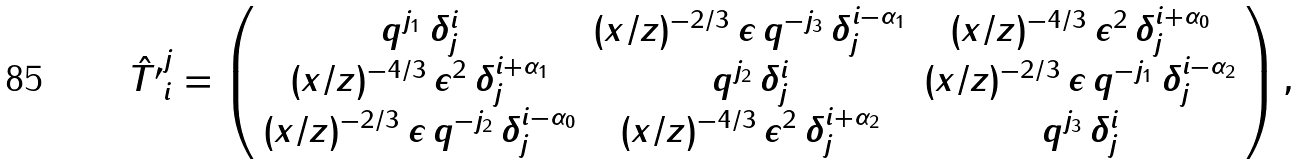Convert formula to latex. <formula><loc_0><loc_0><loc_500><loc_500>\hat { T ^ { \prime } } ^ { j } _ { i } = \left ( \begin{array} { c c c } q ^ { j _ { 1 } } \, \delta ^ { i } _ { j } & ( x / z ) ^ { - 2 / 3 } \, \epsilon \, q ^ { - j _ { 3 } } \, \delta _ { j } ^ { i - \alpha _ { 1 } } & ( x / z ) ^ { - 4 / 3 } \, \epsilon ^ { 2 } \, \delta ^ { i + \alpha _ { 0 } } _ { j } \\ ( x / z ) ^ { - 4 / 3 } \, \epsilon ^ { 2 } \, \delta _ { j } ^ { i + \alpha _ { 1 } } & q ^ { j _ { 2 } } \, \delta ^ { i } _ { j } & ( x / z ) ^ { - 2 / 3 } \, \epsilon \, q ^ { - j _ { 1 } } \, \delta ^ { i - \alpha _ { 2 } } _ { j } \\ ( x / z ) ^ { - 2 / 3 } \, \epsilon \, q ^ { - j _ { 2 } } \, \delta ^ { i - \alpha _ { 0 } } _ { j } & ( x / z ) ^ { - 4 / 3 } \, \epsilon ^ { 2 } \, \delta ^ { i + \alpha _ { 2 } } _ { j } & q ^ { j _ { 3 } } \, \delta ^ { i } _ { j } \\ \end{array} \right ) ,</formula> 